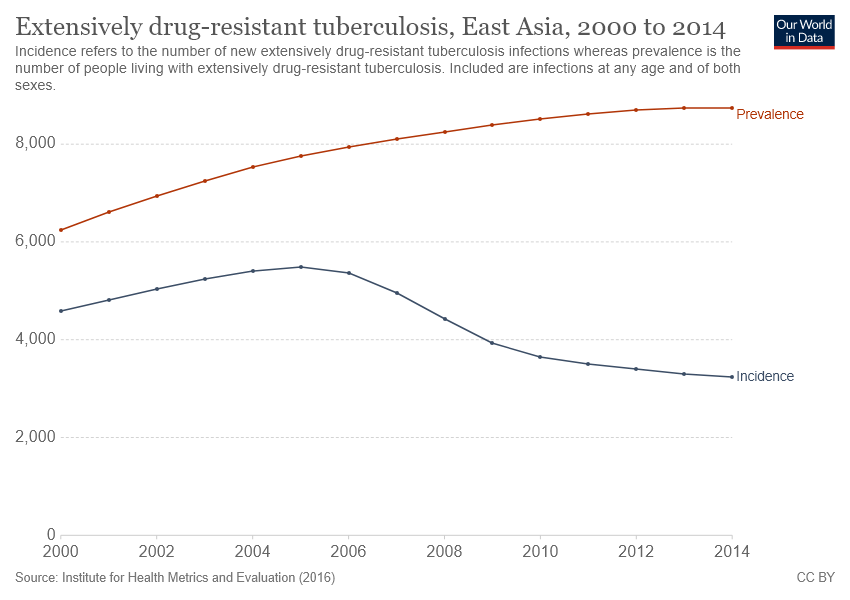Highlight a few significant elements in this photo. In 2014, the difference between the prevalence and incidence of a particular disease was at its greatest point. The red dotted line in 2000 had the lowest value out of all the other years. 